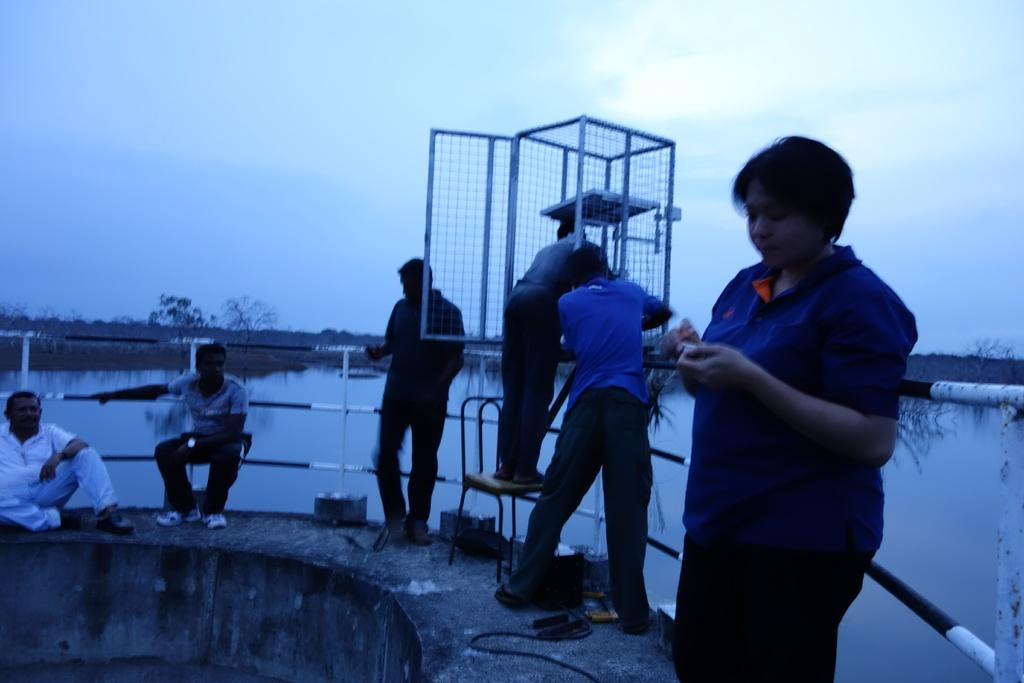How many people are in the group in the image? There is a group of persons in the image. What are the positions of the people in the group? Four of the persons are standing, and the remaining persons are sitting. What can be seen in the background of the image? There is water visible in the background of the image. What type of floor can be seen in the image? There is no floor visible in the image; it features a group of persons with some standing and others sitting, with water visible in the background. 